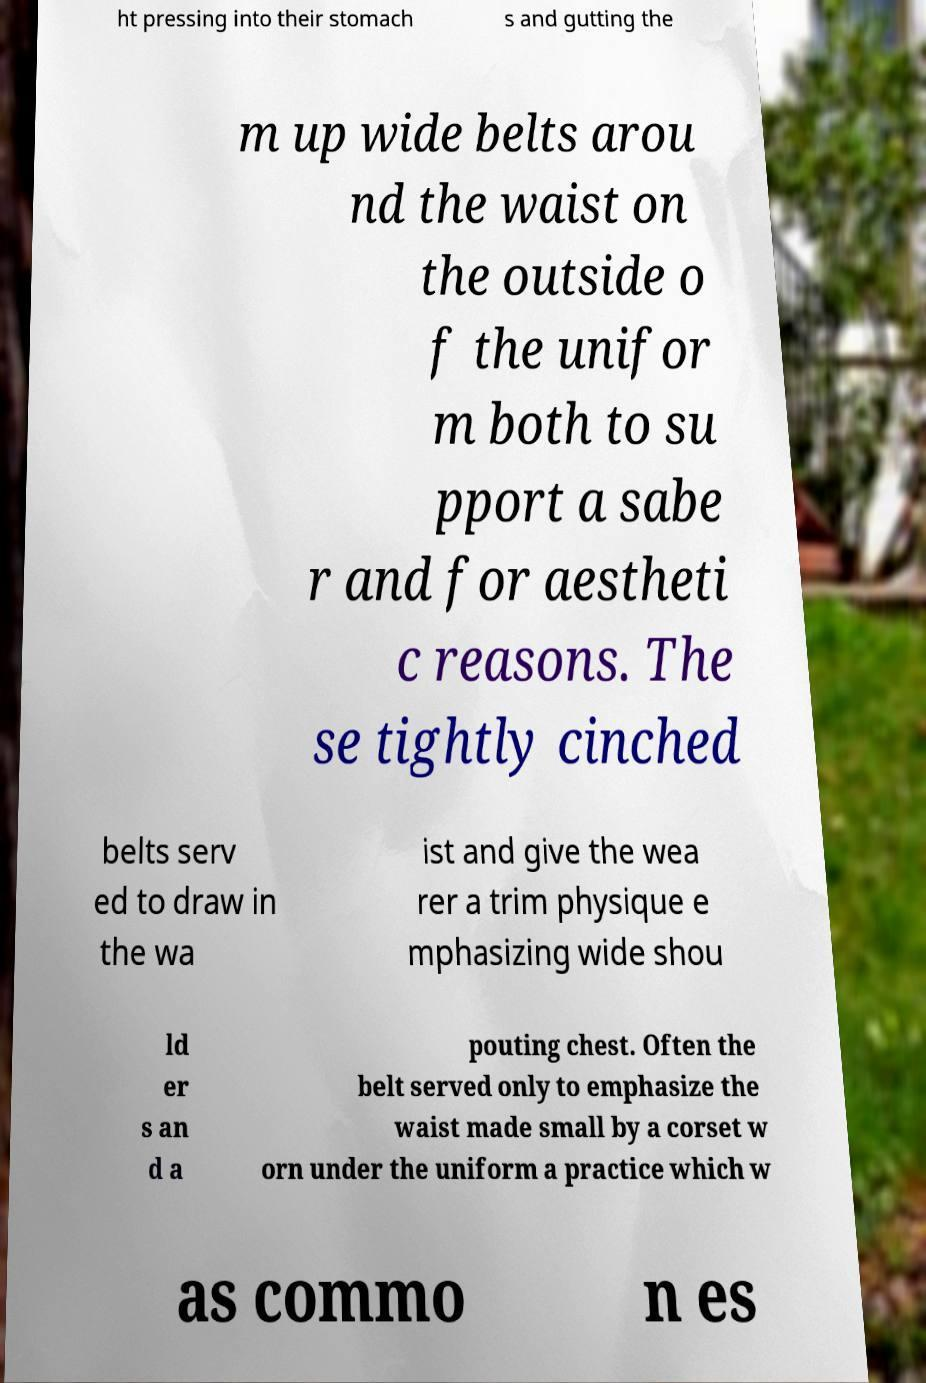Could you assist in decoding the text presented in this image and type it out clearly? ht pressing into their stomach s and gutting the m up wide belts arou nd the waist on the outside o f the unifor m both to su pport a sabe r and for aestheti c reasons. The se tightly cinched belts serv ed to draw in the wa ist and give the wea rer a trim physique e mphasizing wide shou ld er s an d a pouting chest. Often the belt served only to emphasize the waist made small by a corset w orn under the uniform a practice which w as commo n es 